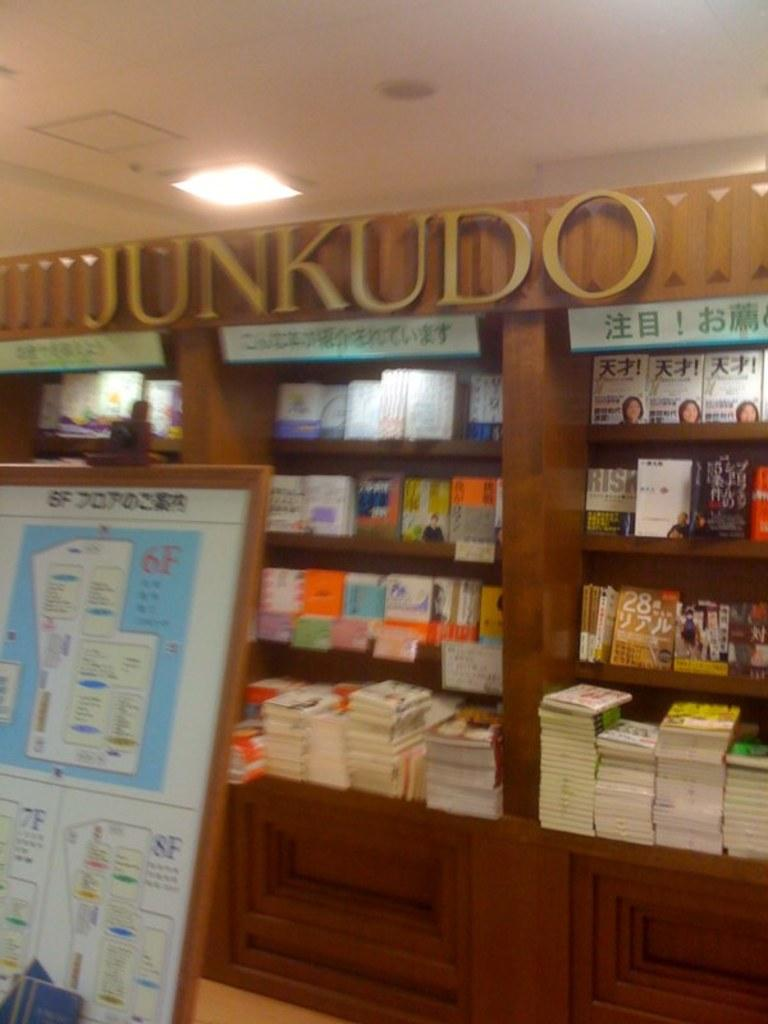What is the main object in the image? There is a board in the image. What is located behind the board? There are books on wooden shelves behind the board. Is there any signage or labeling on the shelves? Yes, there is a name board on top of the shelves. What can be seen at the top of the image? There is a light visible at the top of the image. What type of record is being played on the board in the image? There is no record or music player present in the image; it features a board with books and shelves. Is there an umbrella being used to protect the books from rain in the image? There is no umbrella present in the image, and the image does not suggest that the books are in danger of getting wet. 